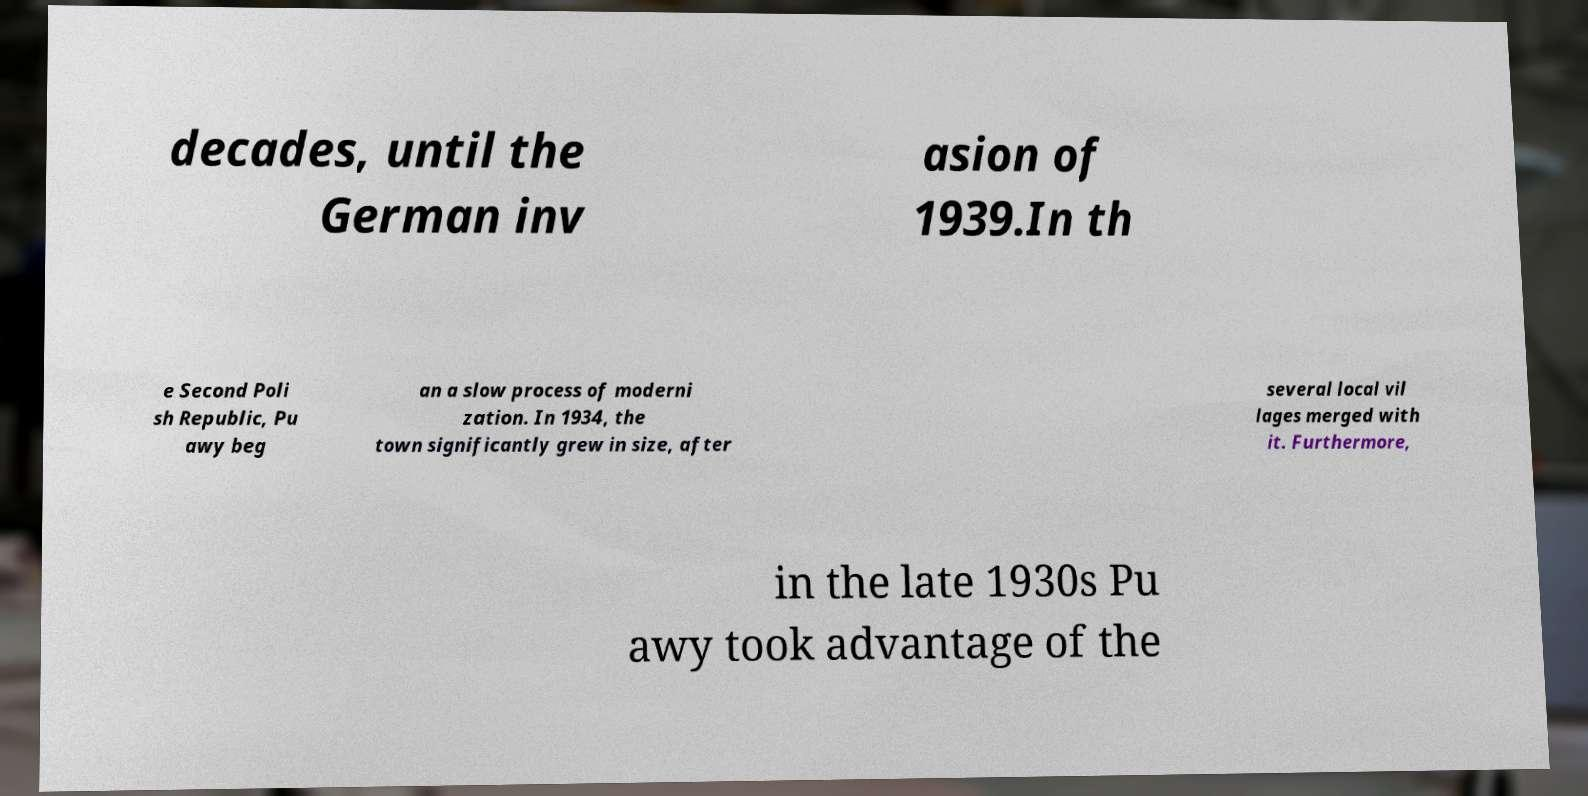Please identify and transcribe the text found in this image. decades, until the German inv asion of 1939.In th e Second Poli sh Republic, Pu awy beg an a slow process of moderni zation. In 1934, the town significantly grew in size, after several local vil lages merged with it. Furthermore, in the late 1930s Pu awy took advantage of the 